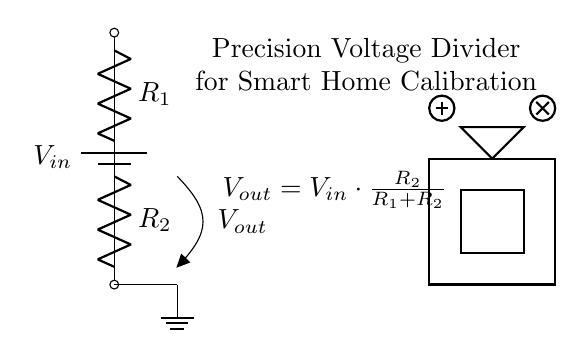What is the input voltage? The input voltage is labeled as V in the circuit diagram. It represents the total voltage supplied from the power source.
Answer: V in What are the components used in this voltage divider? The components used are two resistors denoted as R one and R two. These resistors are essential for dividing the input voltage into a lower output voltage.
Answer: R one, R two What is the output voltage formula? The output voltage formula is given as V out equals V in multiplied by the fraction of R two over the total of R one and R two. This formula derives the output based on the resistance values.
Answer: V out equals V in times R two over R one plus R two If R one is ten ohms and R two is twenty ohms, what is V out if V in is thirty volts? To find the output voltage, substitute the values into the formula: V out equals thirty volts times twenty over ten plus twenty, which results in V out equals ten volts.
Answer: Ten volts Why is a precision voltage divider important for smart home automation? A precision voltage divider ensures accurate calibration of voltage levels in smart home devices, enabling reliable performance and safety in luxury real estate applications. It is critical for calibrating sensors and devices that control home automation systems.
Answer: Accuracy 